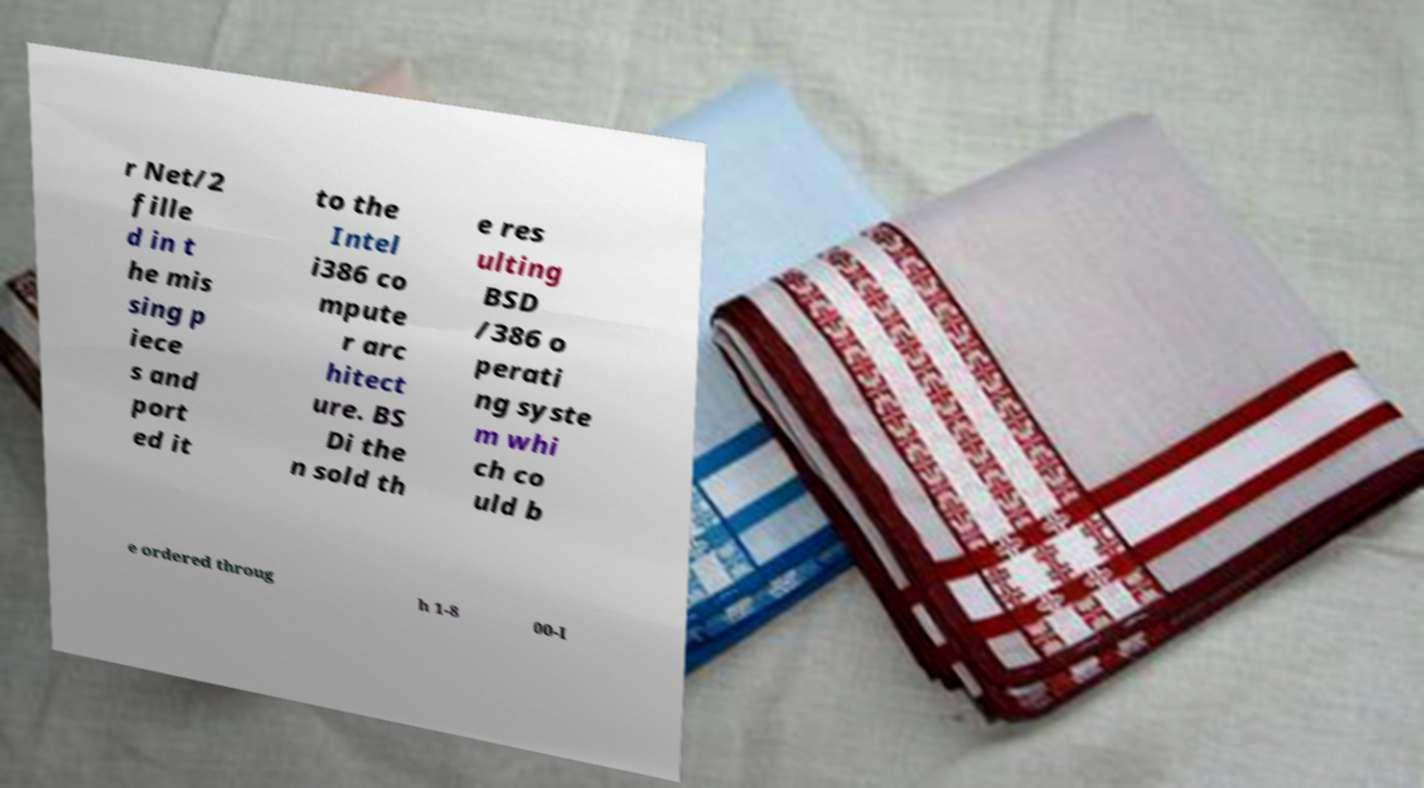Could you extract and type out the text from this image? r Net/2 fille d in t he mis sing p iece s and port ed it to the Intel i386 co mpute r arc hitect ure. BS Di the n sold th e res ulting BSD /386 o perati ng syste m whi ch co uld b e ordered throug h 1-8 00-I 